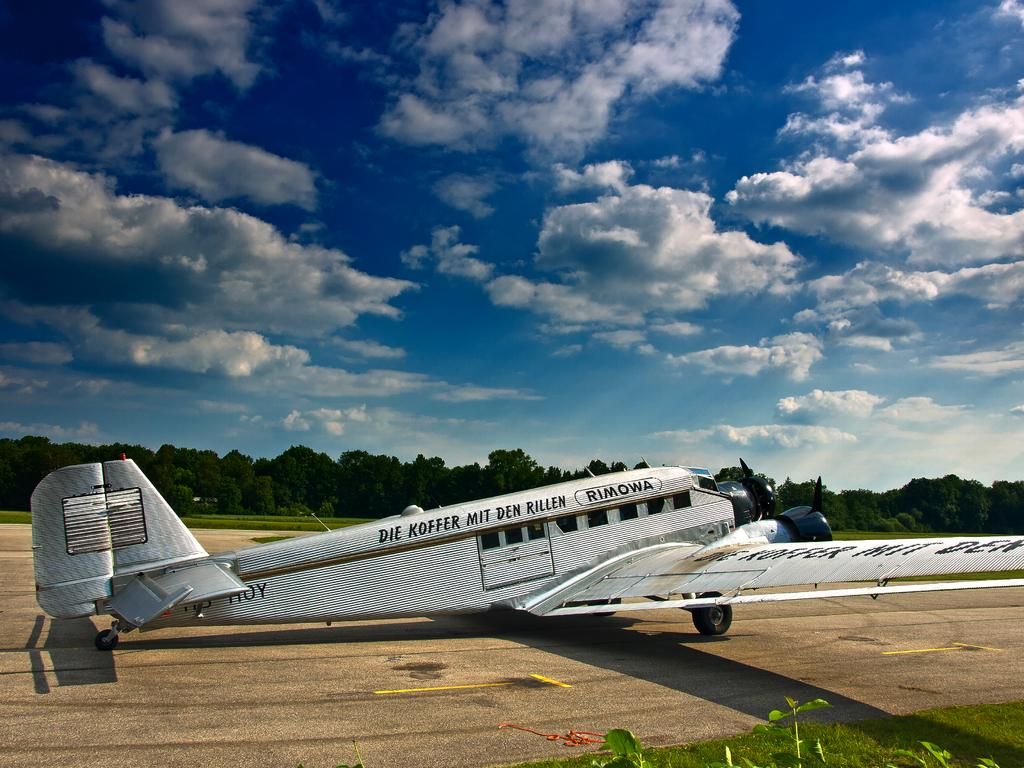What is the main subject of the image? The main subject of the image is an airplane on the ground. What can be seen in the image besides the airplane? There are trees visible in the image. What is visible in the background of the image? The sky with clouds is visible in the background of the image. How many knots are tied on the rail in the image? There is no rail or knots present in the image. What type of railway is visible in the image? There is no railway present in the image; it features an airplane on the ground with trees and a sky with clouds in the background. 